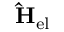<formula> <loc_0><loc_0><loc_500><loc_500>\hat { H } _ { e l }</formula> 